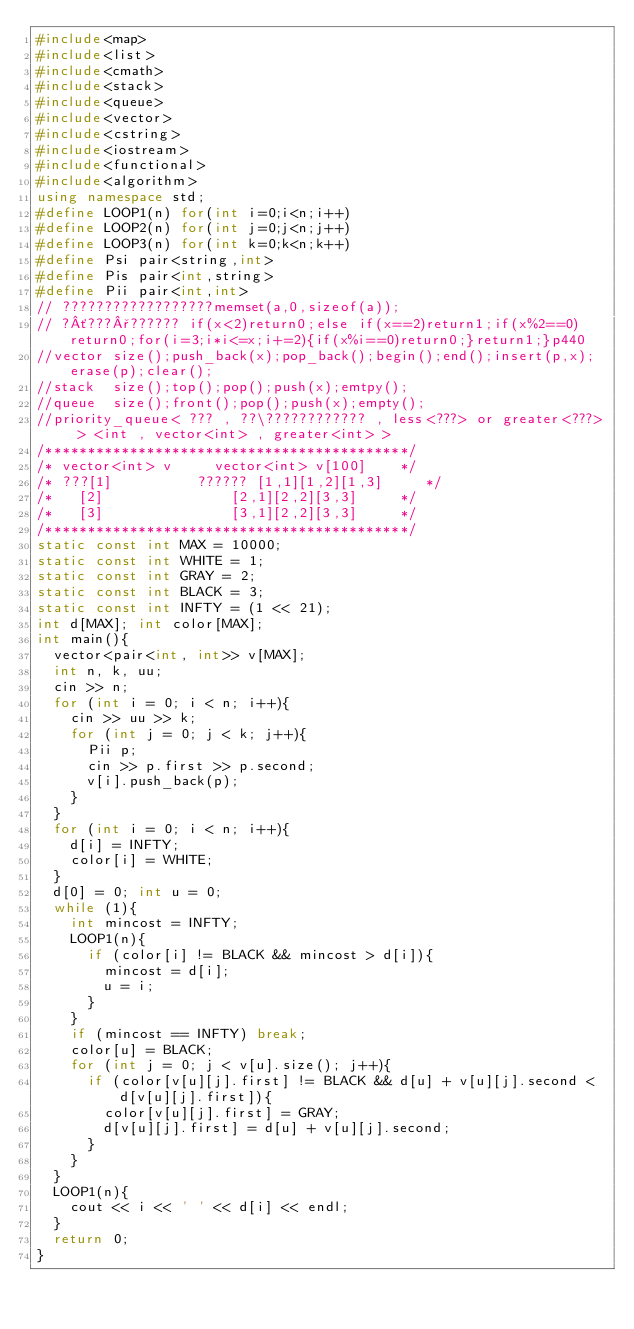Convert code to text. <code><loc_0><loc_0><loc_500><loc_500><_C++_>#include<map>
#include<list>
#include<cmath>
#include<stack>
#include<queue>
#include<vector>
#include<cstring>
#include<iostream>
#include<functional>
#include<algorithm>
using namespace std;
#define LOOP1(n) for(int i=0;i<n;i++)
#define LOOP2(n) for(int j=0;j<n;j++)
#define LOOP3(n) for(int k=0;k<n;k++)
#define Psi pair<string,int>
#define Pis pair<int,string>
#define Pii pair<int,int>
// ??????????????????memset(a,0,sizeof(a));
// ?´???°?????? if(x<2)return0;else if(x==2)return1;if(x%2==0)return0;for(i=3;i*i<=x;i+=2){if(x%i==0)return0;}return1;}p440
//vector size();push_back(x);pop_back();begin();end();insert(p,x);erase(p);clear();
//stack  size();top();pop();push(x);emtpy();
//queue  size();front();pop();push(x);empty();
//priority_queue< ??? , ??\???????????? , less<???> or greater<???> > <int , vector<int> , greater<int> >
/*******************************************/
/* vector<int> v     vector<int> v[100]    */
/* ???[1]          ?????? [1,1][1,2][1,3]     */
/*   [2]               [2,1][2,2][3,3]     */
/*   [3]               [3,1][2,2][3,3]     */
/*******************************************/
static const int MAX = 10000;
static const int WHITE = 1;
static const int GRAY = 2;
static const int BLACK = 3;
static const int INFTY = (1 << 21);
int d[MAX]; int color[MAX]; 
int main(){
	vector<pair<int, int>> v[MAX];
	int n, k, uu;
	cin >> n;
	for (int i = 0; i < n; i++){
		cin >> uu >> k;
		for (int j = 0; j < k; j++){
			Pii p;
			cin >> p.first >> p.second;
			v[i].push_back(p);
		}
	}
	for (int i = 0; i < n; i++){
		d[i] = INFTY;
		color[i] = WHITE;
	}
	d[0] = 0; int u = 0;
	while (1){
		int mincost = INFTY;
		LOOP1(n){
			if (color[i] != BLACK && mincost > d[i]){
				mincost = d[i];
				u = i;
			}
		}
		if (mincost == INFTY) break;
		color[u] = BLACK;
		for (int j = 0; j < v[u].size(); j++){
			if (color[v[u][j].first] != BLACK && d[u] + v[u][j].second < d[v[u][j].first]){
				color[v[u][j].first] = GRAY;
				d[v[u][j].first] = d[u] + v[u][j].second;
			}
		}
	}
	LOOP1(n){
		cout << i << ' ' << d[i] << endl;
	}
	return 0;
}</code> 